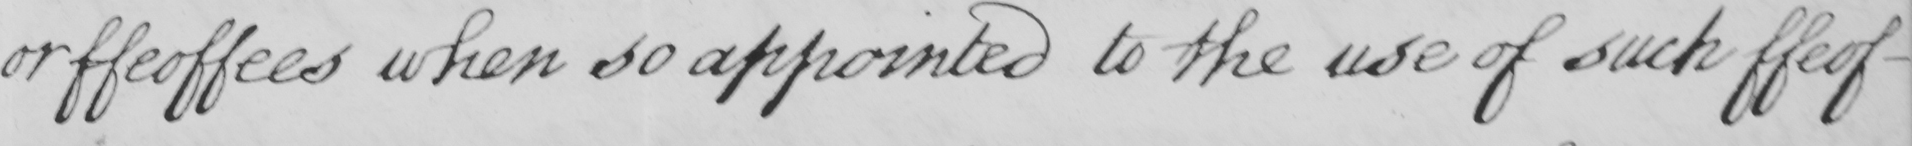Transcribe the text shown in this historical manuscript line. or ffeoffees when so appointed to the use of such ffeof- 